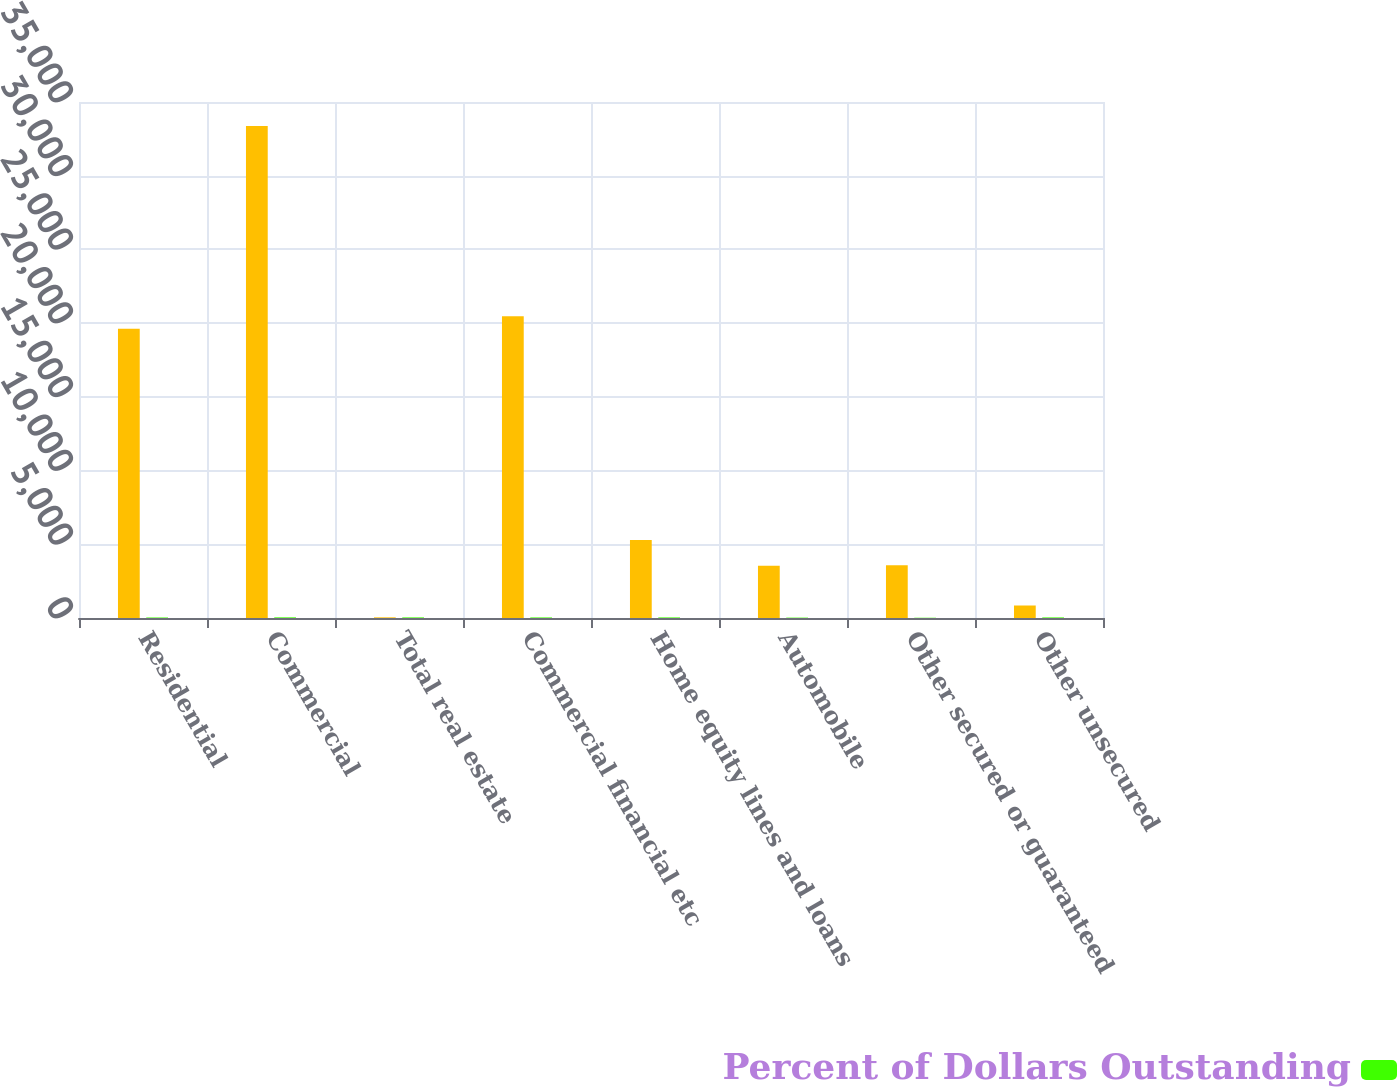Convert chart to OTSL. <chart><loc_0><loc_0><loc_500><loc_500><stacked_bar_chart><ecel><fcel>Residential<fcel>Commercial<fcel>Total real estate<fcel>Commercial financial etc<fcel>Home equity lines and loans<fcel>Automobile<fcel>Other secured or guaranteed<fcel>Other unsecured<nl><fcel>nan<fcel>19613<fcel>33366<fcel>44<fcel>20463<fcel>5294<fcel>3544<fcel>3581<fcel>848<nl><fcel>Percent of Dollars Outstanding<fcel>35<fcel>44<fcel>41<fcel>39<fcel>40<fcel>26<fcel>18<fcel>40<nl></chart> 